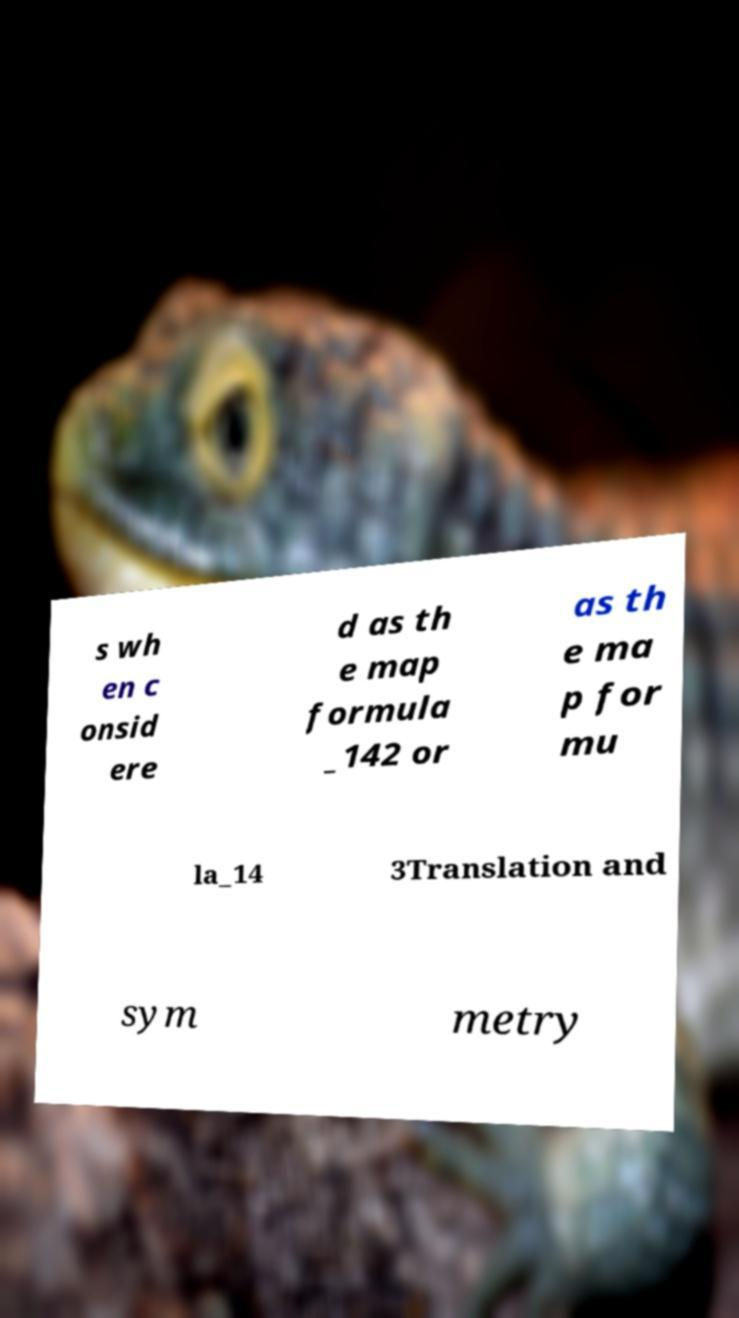There's text embedded in this image that I need extracted. Can you transcribe it verbatim? s wh en c onsid ere d as th e map formula _142 or as th e ma p for mu la_14 3Translation and sym metry 